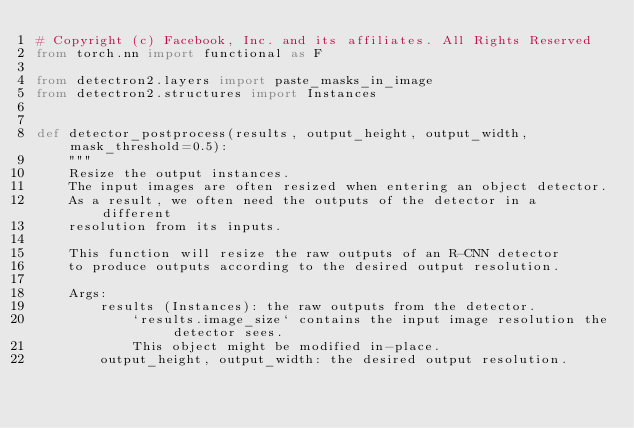Convert code to text. <code><loc_0><loc_0><loc_500><loc_500><_Python_># Copyright (c) Facebook, Inc. and its affiliates. All Rights Reserved
from torch.nn import functional as F

from detectron2.layers import paste_masks_in_image
from detectron2.structures import Instances


def detector_postprocess(results, output_height, output_width, mask_threshold=0.5):
    """
    Resize the output instances.
    The input images are often resized when entering an object detector.
    As a result, we often need the outputs of the detector in a different
    resolution from its inputs.

    This function will resize the raw outputs of an R-CNN detector
    to produce outputs according to the desired output resolution.

    Args:
        results (Instances): the raw outputs from the detector.
            `results.image_size` contains the input image resolution the detector sees.
            This object might be modified in-place.
        output_height, output_width: the desired output resolution.
</code> 